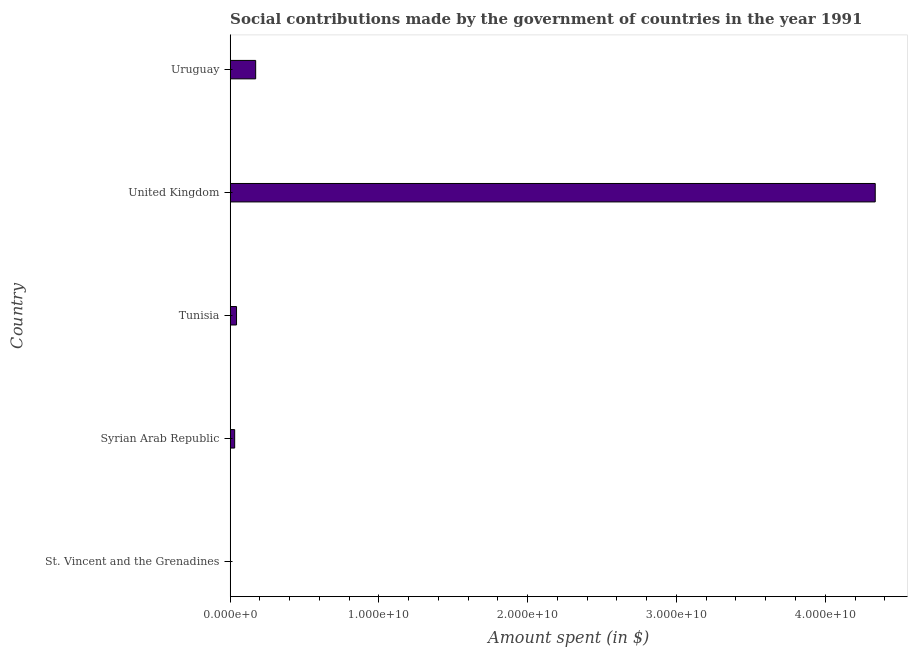Does the graph contain grids?
Provide a short and direct response. No. What is the title of the graph?
Your answer should be very brief. Social contributions made by the government of countries in the year 1991. What is the label or title of the X-axis?
Your answer should be very brief. Amount spent (in $). What is the amount spent in making social contributions in Tunisia?
Make the answer very short. 4.26e+08. Across all countries, what is the maximum amount spent in making social contributions?
Provide a short and direct response. 4.34e+1. Across all countries, what is the minimum amount spent in making social contributions?
Ensure brevity in your answer.  8.70e+06. In which country was the amount spent in making social contributions minimum?
Make the answer very short. St. Vincent and the Grenadines. What is the sum of the amount spent in making social contributions?
Offer a very short reply. 4.58e+1. What is the difference between the amount spent in making social contributions in Tunisia and Uruguay?
Provide a short and direct response. -1.29e+09. What is the average amount spent in making social contributions per country?
Your answer should be very brief. 9.16e+09. What is the median amount spent in making social contributions?
Provide a succinct answer. 4.26e+08. Is the amount spent in making social contributions in St. Vincent and the Grenadines less than that in Syrian Arab Republic?
Your answer should be compact. Yes. Is the difference between the amount spent in making social contributions in St. Vincent and the Grenadines and Syrian Arab Republic greater than the difference between any two countries?
Give a very brief answer. No. What is the difference between the highest and the second highest amount spent in making social contributions?
Your response must be concise. 4.16e+1. What is the difference between the highest and the lowest amount spent in making social contributions?
Your answer should be very brief. 4.34e+1. What is the difference between two consecutive major ticks on the X-axis?
Ensure brevity in your answer.  1.00e+1. What is the Amount spent (in $) in St. Vincent and the Grenadines?
Your response must be concise. 8.70e+06. What is the Amount spent (in $) of Syrian Arab Republic?
Provide a short and direct response. 3.02e+08. What is the Amount spent (in $) in Tunisia?
Provide a succinct answer. 4.26e+08. What is the Amount spent (in $) in United Kingdom?
Make the answer very short. 4.34e+1. What is the Amount spent (in $) of Uruguay?
Offer a very short reply. 1.71e+09. What is the difference between the Amount spent (in $) in St. Vincent and the Grenadines and Syrian Arab Republic?
Provide a short and direct response. -2.93e+08. What is the difference between the Amount spent (in $) in St. Vincent and the Grenadines and Tunisia?
Your answer should be very brief. -4.18e+08. What is the difference between the Amount spent (in $) in St. Vincent and the Grenadines and United Kingdom?
Your answer should be compact. -4.34e+1. What is the difference between the Amount spent (in $) in St. Vincent and the Grenadines and Uruguay?
Ensure brevity in your answer.  -1.70e+09. What is the difference between the Amount spent (in $) in Syrian Arab Republic and Tunisia?
Give a very brief answer. -1.24e+08. What is the difference between the Amount spent (in $) in Syrian Arab Republic and United Kingdom?
Your answer should be very brief. -4.31e+1. What is the difference between the Amount spent (in $) in Syrian Arab Republic and Uruguay?
Ensure brevity in your answer.  -1.41e+09. What is the difference between the Amount spent (in $) in Tunisia and United Kingdom?
Your answer should be compact. -4.29e+1. What is the difference between the Amount spent (in $) in Tunisia and Uruguay?
Provide a short and direct response. -1.29e+09. What is the difference between the Amount spent (in $) in United Kingdom and Uruguay?
Ensure brevity in your answer.  4.16e+1. What is the ratio of the Amount spent (in $) in St. Vincent and the Grenadines to that in Syrian Arab Republic?
Provide a short and direct response. 0.03. What is the ratio of the Amount spent (in $) in St. Vincent and the Grenadines to that in Tunisia?
Provide a succinct answer. 0.02. What is the ratio of the Amount spent (in $) in St. Vincent and the Grenadines to that in Uruguay?
Your answer should be compact. 0.01. What is the ratio of the Amount spent (in $) in Syrian Arab Republic to that in Tunisia?
Give a very brief answer. 0.71. What is the ratio of the Amount spent (in $) in Syrian Arab Republic to that in United Kingdom?
Provide a succinct answer. 0.01. What is the ratio of the Amount spent (in $) in Syrian Arab Republic to that in Uruguay?
Offer a very short reply. 0.18. What is the ratio of the Amount spent (in $) in Tunisia to that in United Kingdom?
Provide a succinct answer. 0.01. What is the ratio of the Amount spent (in $) in Tunisia to that in Uruguay?
Provide a succinct answer. 0.25. What is the ratio of the Amount spent (in $) in United Kingdom to that in Uruguay?
Your answer should be compact. 25.31. 